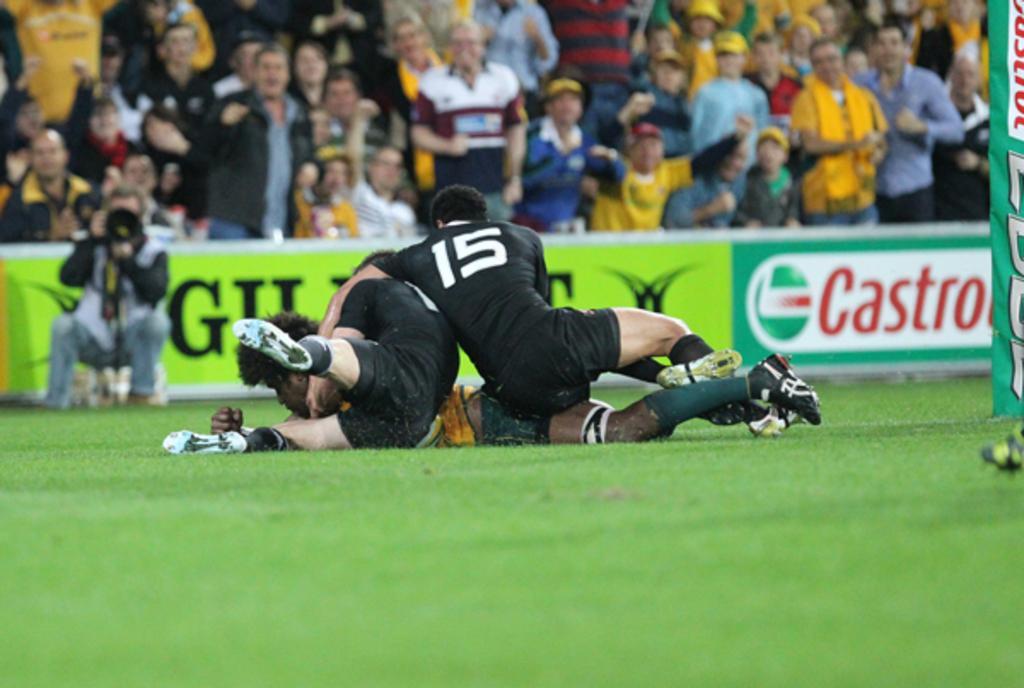In one or two sentences, can you explain what this image depicts? At the bottom of the image on the ground there is grass. And also there are few players on the ground. Behind them on the left side there is a man holding a video camera in his hand. Behind them there are banners with text on it. Behind the banners there are few people. On the right corner of the image there is a banner with text on it. 